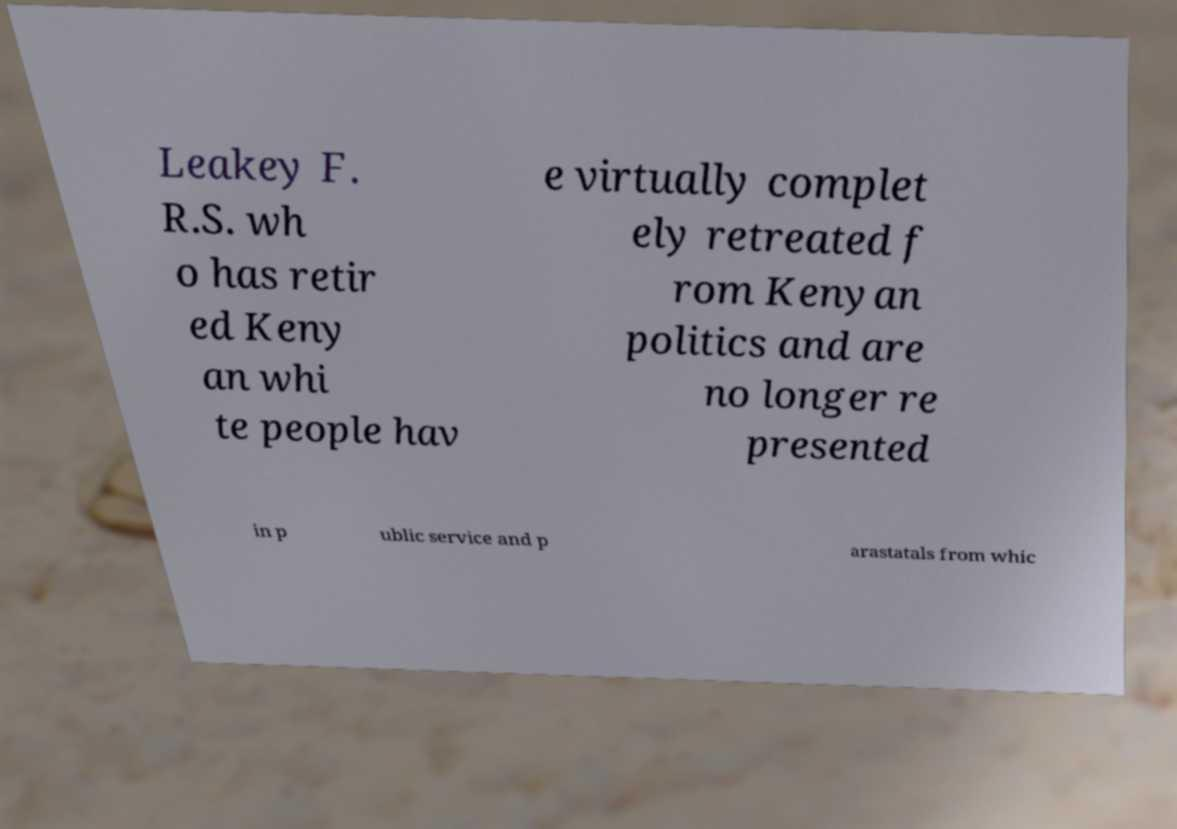For documentation purposes, I need the text within this image transcribed. Could you provide that? Leakey F. R.S. wh o has retir ed Keny an whi te people hav e virtually complet ely retreated f rom Kenyan politics and are no longer re presented in p ublic service and p arastatals from whic 